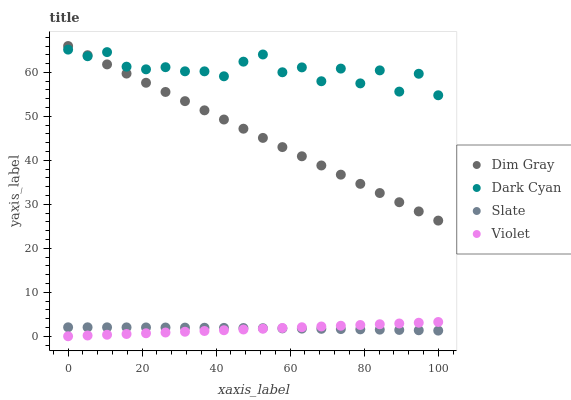Does Violet have the minimum area under the curve?
Answer yes or no. Yes. Does Dark Cyan have the maximum area under the curve?
Answer yes or no. Yes. Does Slate have the minimum area under the curve?
Answer yes or no. No. Does Slate have the maximum area under the curve?
Answer yes or no. No. Is Violet the smoothest?
Answer yes or no. Yes. Is Dark Cyan the roughest?
Answer yes or no. Yes. Is Slate the smoothest?
Answer yes or no. No. Is Slate the roughest?
Answer yes or no. No. Does Violet have the lowest value?
Answer yes or no. Yes. Does Slate have the lowest value?
Answer yes or no. No. Does Dim Gray have the highest value?
Answer yes or no. Yes. Does Slate have the highest value?
Answer yes or no. No. Is Slate less than Dark Cyan?
Answer yes or no. Yes. Is Dim Gray greater than Slate?
Answer yes or no. Yes. Does Violet intersect Slate?
Answer yes or no. Yes. Is Violet less than Slate?
Answer yes or no. No. Is Violet greater than Slate?
Answer yes or no. No. Does Slate intersect Dark Cyan?
Answer yes or no. No. 